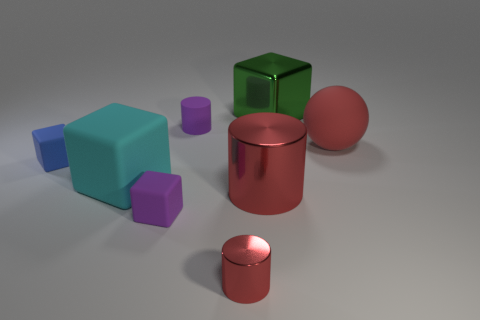Add 1 small purple matte objects. How many objects exist? 9 Subtract 1 cubes. How many cubes are left? 3 Subtract all big green shiny blocks. How many blocks are left? 3 Subtract all cyan cubes. How many cubes are left? 3 Subtract all balls. How many objects are left? 7 Subtract all red blocks. Subtract all green spheres. How many blocks are left? 4 Subtract all big matte balls. Subtract all metal cylinders. How many objects are left? 5 Add 7 big shiny cylinders. How many big shiny cylinders are left? 8 Add 8 big purple rubber spheres. How many big purple rubber spheres exist? 8 Subtract 0 green cylinders. How many objects are left? 8 